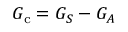<formula> <loc_0><loc_0><loc_500><loc_500>G _ { c } = G _ { S } - G _ { A }</formula> 